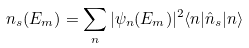<formula> <loc_0><loc_0><loc_500><loc_500>n _ { s } ( E _ { m } ) = \sum _ { n } | \psi _ { n } ( E _ { m } ) | ^ { 2 } \langle { n } | \hat { n } _ { s } | { n } \rangle</formula> 